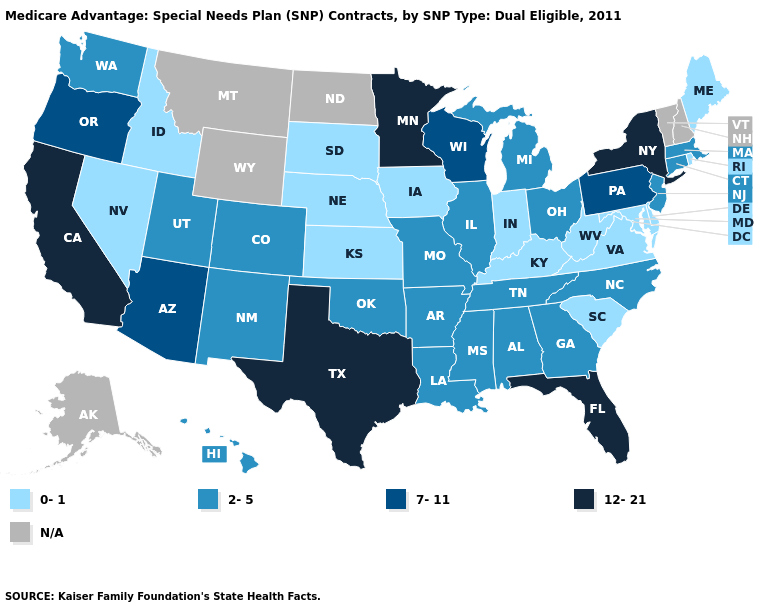How many symbols are there in the legend?
Keep it brief. 5. Does the first symbol in the legend represent the smallest category?
Quick response, please. Yes. Name the states that have a value in the range 12-21?
Give a very brief answer. California, Florida, Minnesota, New York, Texas. How many symbols are there in the legend?
Quick response, please. 5. What is the value of Nevada?
Concise answer only. 0-1. What is the value of Arkansas?
Be succinct. 2-5. What is the value of Connecticut?
Answer briefly. 2-5. Name the states that have a value in the range 0-1?
Be succinct. Delaware, Iowa, Idaho, Indiana, Kansas, Kentucky, Maryland, Maine, Nebraska, Nevada, Rhode Island, South Carolina, South Dakota, Virginia, West Virginia. What is the lowest value in the South?
Keep it brief. 0-1. Which states have the highest value in the USA?
Give a very brief answer. California, Florida, Minnesota, New York, Texas. Name the states that have a value in the range 0-1?
Keep it brief. Delaware, Iowa, Idaho, Indiana, Kansas, Kentucky, Maryland, Maine, Nebraska, Nevada, Rhode Island, South Carolina, South Dakota, Virginia, West Virginia. What is the value of Pennsylvania?
Be succinct. 7-11. Does the map have missing data?
Concise answer only. Yes. 